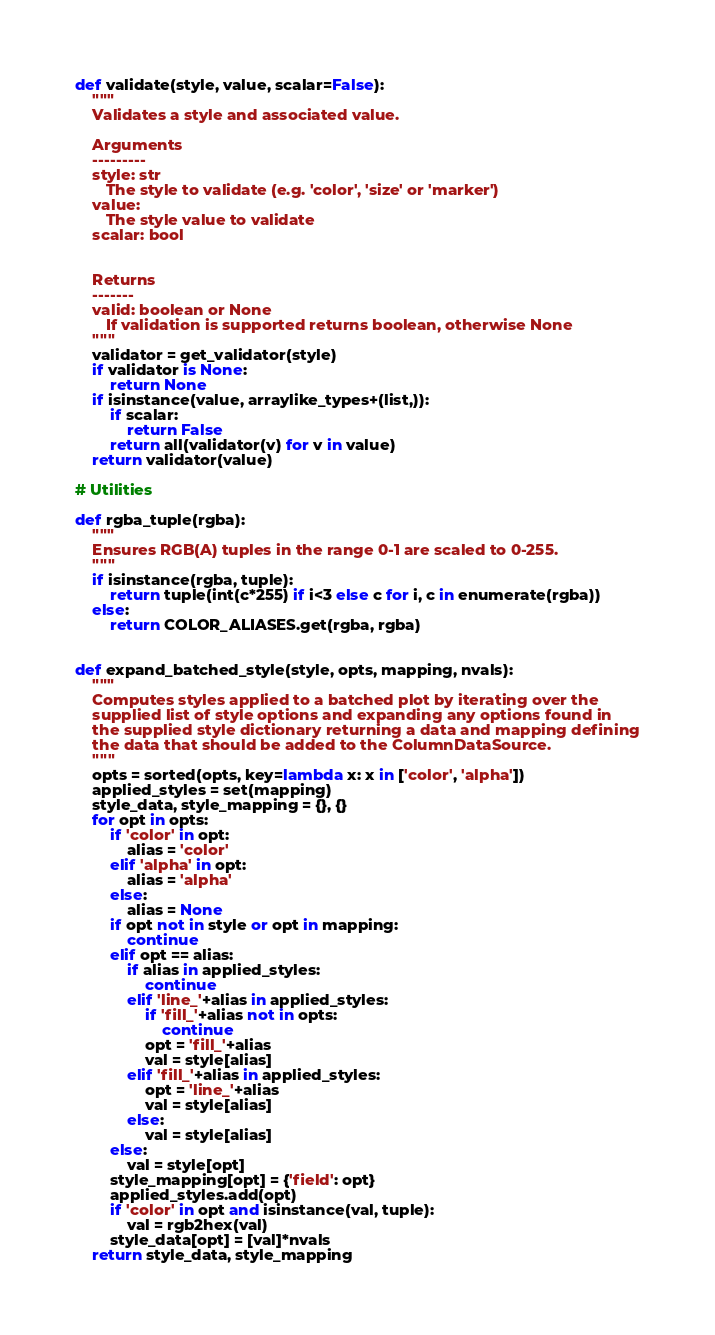Convert code to text. <code><loc_0><loc_0><loc_500><loc_500><_Python_>
def validate(style, value, scalar=False):
    """
    Validates a style and associated value.

    Arguments
    ---------
    style: str
       The style to validate (e.g. 'color', 'size' or 'marker')
    value: 
       The style value to validate
    scalar: bool


    Returns
    -------
    valid: boolean or None
       If validation is supported returns boolean, otherwise None
    """
    validator = get_validator(style)
    if validator is None:
        return None
    if isinstance(value, arraylike_types+(list,)):
        if scalar:
            return False
        return all(validator(v) for v in value)
    return validator(value)

# Utilities

def rgba_tuple(rgba):
    """
    Ensures RGB(A) tuples in the range 0-1 are scaled to 0-255.
    """
    if isinstance(rgba, tuple):
        return tuple(int(c*255) if i<3 else c for i, c in enumerate(rgba))
    else:
        return COLOR_ALIASES.get(rgba, rgba)


def expand_batched_style(style, opts, mapping, nvals):
    """
    Computes styles applied to a batched plot by iterating over the
    supplied list of style options and expanding any options found in
    the supplied style dictionary returning a data and mapping defining
    the data that should be added to the ColumnDataSource.
    """
    opts = sorted(opts, key=lambda x: x in ['color', 'alpha'])
    applied_styles = set(mapping)
    style_data, style_mapping = {}, {}
    for opt in opts:
        if 'color' in opt:
            alias = 'color'
        elif 'alpha' in opt:
            alias = 'alpha'
        else:
            alias = None
        if opt not in style or opt in mapping:
            continue
        elif opt == alias:
            if alias in applied_styles:
                continue
            elif 'line_'+alias in applied_styles:
                if 'fill_'+alias not in opts:
                    continue
                opt = 'fill_'+alias
                val = style[alias]
            elif 'fill_'+alias in applied_styles:
                opt = 'line_'+alias
                val = style[alias]
            else:
                val = style[alias]
        else:
            val = style[opt]
        style_mapping[opt] = {'field': opt}
        applied_styles.add(opt)
        if 'color' in opt and isinstance(val, tuple):
            val = rgb2hex(val)
        style_data[opt] = [val]*nvals
    return style_data, style_mapping
</code> 